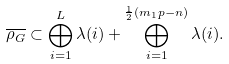<formula> <loc_0><loc_0><loc_500><loc_500>\overline { \rho _ { G } } \subset \bigoplus _ { i = 1 } ^ { L } \lambda ( i ) + \bigoplus _ { i = 1 } ^ { \frac { 1 } { 2 } ( m _ { 1 } p - n ) } \lambda ( i ) .</formula> 